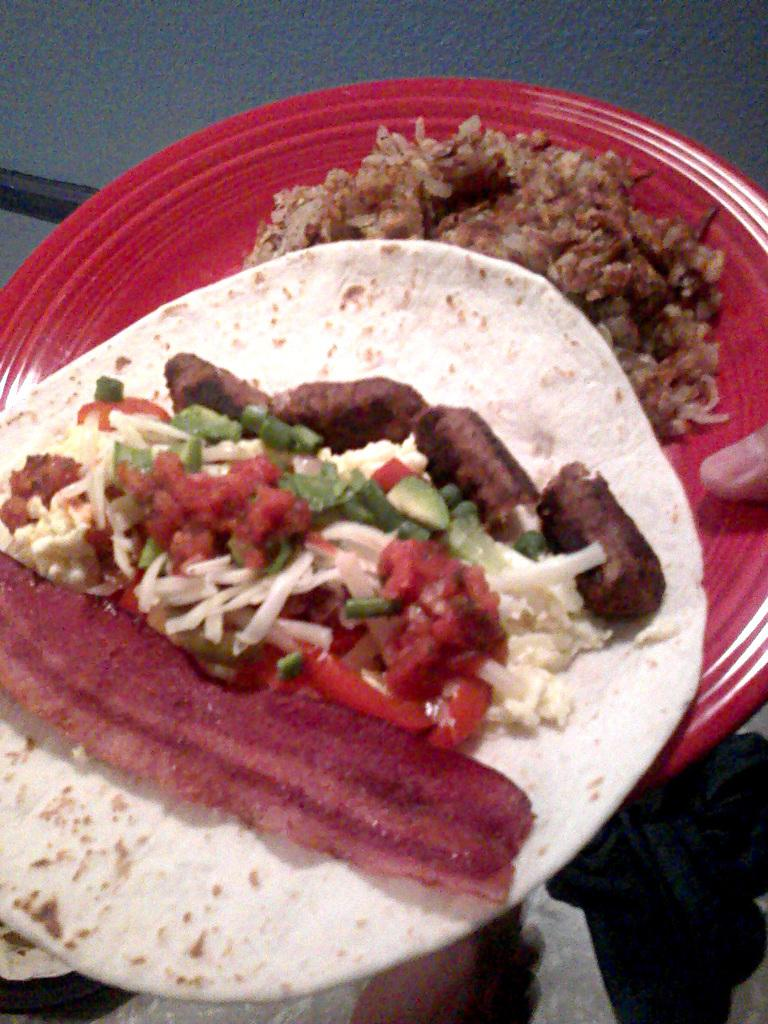What is being held by a person's hand in the image? There is a person's hand holding a plate in the image. What color is the plate? The plate is red in color. What type of food is on the plate? There is rice on the plate, and there is also a Chapati with curry on it. What type of appliance is being used to cook the curry in the image? There is no appliance visible in the image; it only shows a plate with rice and a Chapati with curry. Can you see the person's feet in the image? The image does not show the person's feet; it only shows a hand holding a plate. 